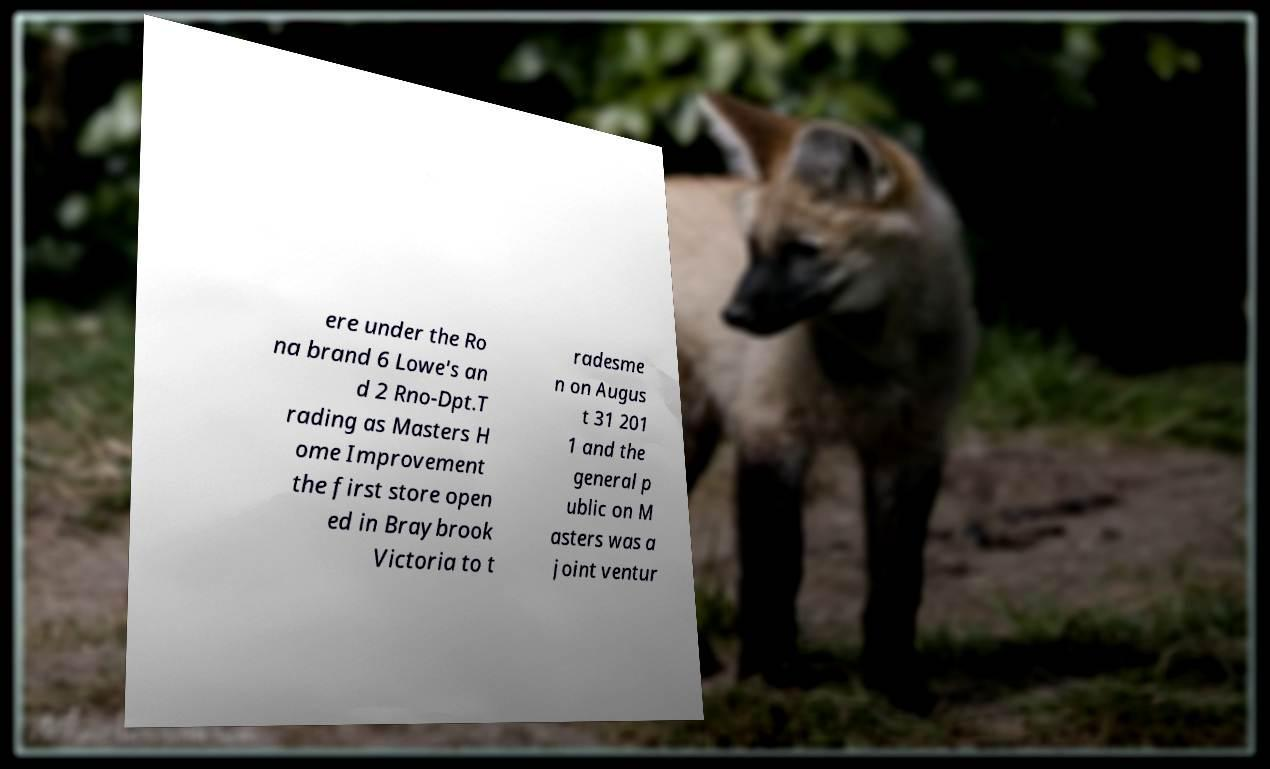Could you extract and type out the text from this image? ere under the Ro na brand 6 Lowe's an d 2 Rno-Dpt.T rading as Masters H ome Improvement the first store open ed in Braybrook Victoria to t radesme n on Augus t 31 201 1 and the general p ublic on M asters was a joint ventur 